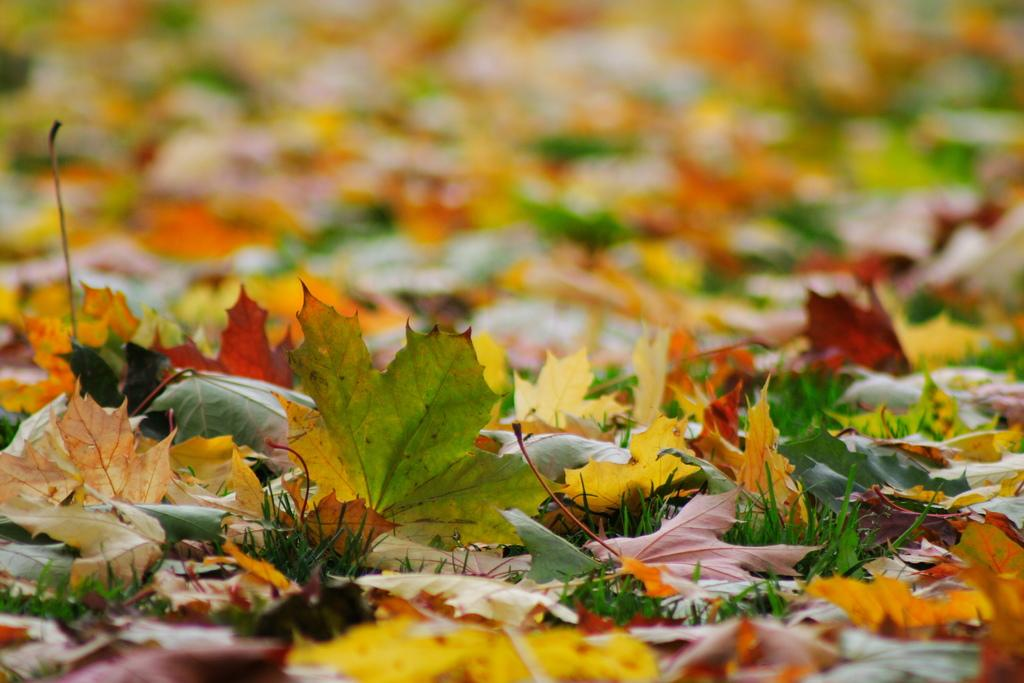What type of vegetation can be seen in the image? There is grass in the image. What else can be seen in the image besides grass? There are leaves in the image. How would you describe the background of the image? The background of the image is blurred. Can you tell me how many curtains are hanging in the image? There are no curtains present in the image. What type of expert is providing advice in the image? There is no expert present in the image. 